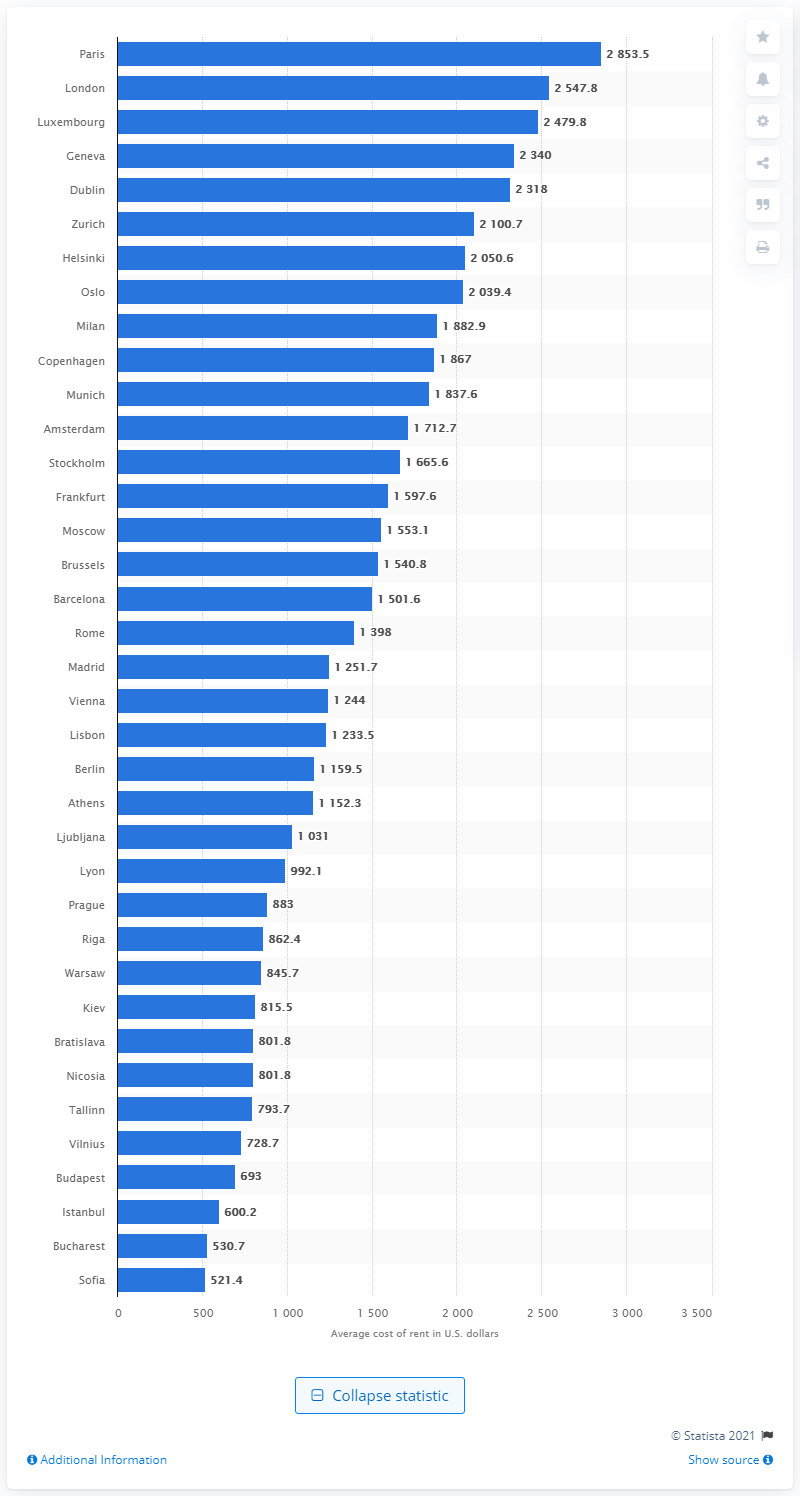Outline some significant characteristics in this image. London is the city with an average rental cost of less than 300 U.S. dollars than the Capital of France. Paris spent approximately 2,853.5 dollars per month to rent an apartment. Moscow has a lower rental cost than Paris in Western Europe. 